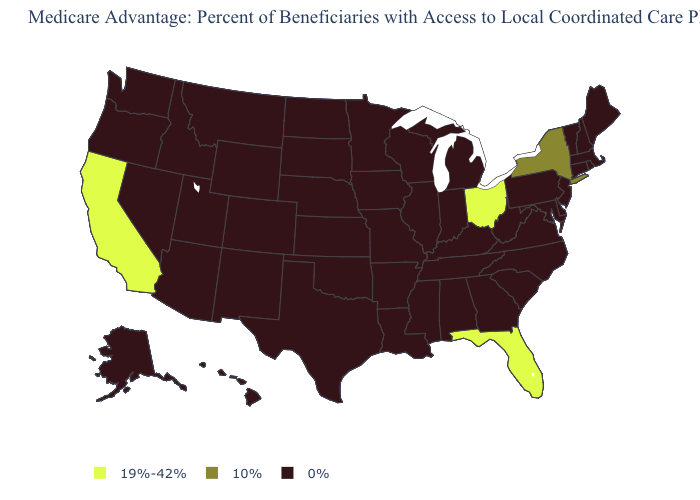Name the states that have a value in the range 19%-42%?
Answer briefly. California, Florida, Ohio. What is the lowest value in the USA?
Quick response, please. 0%. Is the legend a continuous bar?
Answer briefly. No. Name the states that have a value in the range 0%?
Write a very short answer. Alaska, Alabama, Arkansas, Arizona, Colorado, Connecticut, Delaware, Georgia, Hawaii, Iowa, Idaho, Illinois, Indiana, Kansas, Kentucky, Louisiana, Massachusetts, Maryland, Maine, Michigan, Minnesota, Missouri, Mississippi, Montana, North Carolina, North Dakota, Nebraska, New Hampshire, New Jersey, New Mexico, Nevada, Oklahoma, Oregon, Pennsylvania, Rhode Island, South Carolina, South Dakota, Tennessee, Texas, Utah, Virginia, Vermont, Washington, Wisconsin, West Virginia, Wyoming. Which states have the lowest value in the USA?
Give a very brief answer. Alaska, Alabama, Arkansas, Arizona, Colorado, Connecticut, Delaware, Georgia, Hawaii, Iowa, Idaho, Illinois, Indiana, Kansas, Kentucky, Louisiana, Massachusetts, Maryland, Maine, Michigan, Minnesota, Missouri, Mississippi, Montana, North Carolina, North Dakota, Nebraska, New Hampshire, New Jersey, New Mexico, Nevada, Oklahoma, Oregon, Pennsylvania, Rhode Island, South Carolina, South Dakota, Tennessee, Texas, Utah, Virginia, Vermont, Washington, Wisconsin, West Virginia, Wyoming. Is the legend a continuous bar?
Give a very brief answer. No. What is the value of Tennessee?
Write a very short answer. 0%. Name the states that have a value in the range 19%-42%?
Quick response, please. California, Florida, Ohio. Is the legend a continuous bar?
Keep it brief. No. Does Alabama have the highest value in the South?
Write a very short answer. No. Among the states that border Kentucky , does Ohio have the highest value?
Concise answer only. Yes. Does Ohio have the highest value in the MidWest?
Concise answer only. Yes. What is the value of Montana?
Give a very brief answer. 0%. What is the value of Vermont?
Give a very brief answer. 0%. 